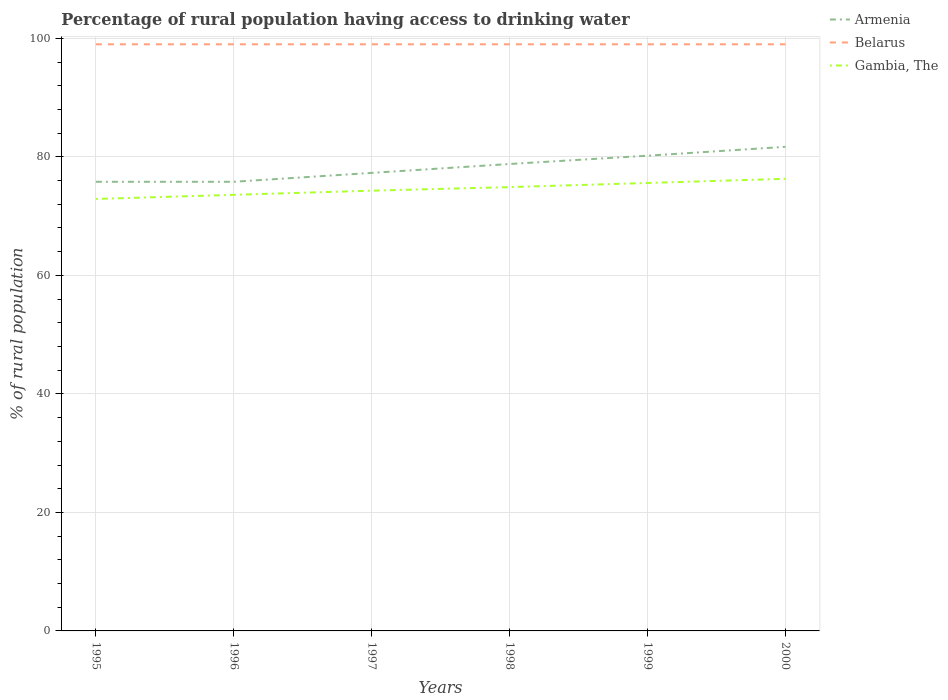Does the line corresponding to Belarus intersect with the line corresponding to Gambia, The?
Your response must be concise. No. Is the number of lines equal to the number of legend labels?
Make the answer very short. Yes. Across all years, what is the maximum percentage of rural population having access to drinking water in Armenia?
Offer a terse response. 75.8. In which year was the percentage of rural population having access to drinking water in Belarus maximum?
Offer a terse response. 1995. What is the total percentage of rural population having access to drinking water in Gambia, The in the graph?
Ensure brevity in your answer.  -0.7. What is the difference between the highest and the second highest percentage of rural population having access to drinking water in Gambia, The?
Provide a succinct answer. 3.4. Is the percentage of rural population having access to drinking water in Belarus strictly greater than the percentage of rural population having access to drinking water in Gambia, The over the years?
Your answer should be compact. No. How many lines are there?
Your response must be concise. 3. How many years are there in the graph?
Offer a terse response. 6. What is the difference between two consecutive major ticks on the Y-axis?
Ensure brevity in your answer.  20. Does the graph contain grids?
Your answer should be very brief. Yes. Where does the legend appear in the graph?
Your answer should be compact. Top right. How many legend labels are there?
Your answer should be very brief. 3. What is the title of the graph?
Give a very brief answer. Percentage of rural population having access to drinking water. What is the label or title of the X-axis?
Offer a very short reply. Years. What is the label or title of the Y-axis?
Provide a succinct answer. % of rural population. What is the % of rural population of Armenia in 1995?
Give a very brief answer. 75.8. What is the % of rural population of Belarus in 1995?
Your answer should be compact. 99. What is the % of rural population of Gambia, The in 1995?
Offer a very short reply. 72.9. What is the % of rural population in Armenia in 1996?
Your answer should be very brief. 75.8. What is the % of rural population of Belarus in 1996?
Give a very brief answer. 99. What is the % of rural population of Gambia, The in 1996?
Give a very brief answer. 73.6. What is the % of rural population of Armenia in 1997?
Provide a short and direct response. 77.3. What is the % of rural population in Gambia, The in 1997?
Ensure brevity in your answer.  74.3. What is the % of rural population in Armenia in 1998?
Offer a very short reply. 78.8. What is the % of rural population of Gambia, The in 1998?
Provide a short and direct response. 74.9. What is the % of rural population of Armenia in 1999?
Provide a succinct answer. 80.2. What is the % of rural population in Gambia, The in 1999?
Offer a terse response. 75.6. What is the % of rural population in Armenia in 2000?
Provide a succinct answer. 81.7. What is the % of rural population of Belarus in 2000?
Ensure brevity in your answer.  99. What is the % of rural population in Gambia, The in 2000?
Offer a terse response. 76.3. Across all years, what is the maximum % of rural population of Armenia?
Offer a very short reply. 81.7. Across all years, what is the maximum % of rural population in Belarus?
Offer a very short reply. 99. Across all years, what is the maximum % of rural population of Gambia, The?
Offer a terse response. 76.3. Across all years, what is the minimum % of rural population of Armenia?
Make the answer very short. 75.8. Across all years, what is the minimum % of rural population of Belarus?
Your response must be concise. 99. Across all years, what is the minimum % of rural population in Gambia, The?
Provide a short and direct response. 72.9. What is the total % of rural population of Armenia in the graph?
Make the answer very short. 469.6. What is the total % of rural population of Belarus in the graph?
Make the answer very short. 594. What is the total % of rural population of Gambia, The in the graph?
Your answer should be compact. 447.6. What is the difference between the % of rural population of Belarus in 1995 and that in 1996?
Your response must be concise. 0. What is the difference between the % of rural population of Armenia in 1995 and that in 1997?
Offer a very short reply. -1.5. What is the difference between the % of rural population of Armenia in 1995 and that in 1998?
Provide a succinct answer. -3. What is the difference between the % of rural population in Belarus in 1995 and that in 1998?
Offer a terse response. 0. What is the difference between the % of rural population in Belarus in 1995 and that in 1999?
Keep it short and to the point. 0. What is the difference between the % of rural population in Belarus in 1995 and that in 2000?
Make the answer very short. 0. What is the difference between the % of rural population of Gambia, The in 1995 and that in 2000?
Ensure brevity in your answer.  -3.4. What is the difference between the % of rural population in Armenia in 1996 and that in 1997?
Make the answer very short. -1.5. What is the difference between the % of rural population in Gambia, The in 1996 and that in 1997?
Your response must be concise. -0.7. What is the difference between the % of rural population in Armenia in 1996 and that in 1998?
Keep it short and to the point. -3. What is the difference between the % of rural population in Belarus in 1996 and that in 1998?
Your answer should be compact. 0. What is the difference between the % of rural population of Armenia in 1996 and that in 1999?
Offer a very short reply. -4.4. What is the difference between the % of rural population of Belarus in 1996 and that in 1999?
Offer a terse response. 0. What is the difference between the % of rural population of Armenia in 1996 and that in 2000?
Ensure brevity in your answer.  -5.9. What is the difference between the % of rural population of Belarus in 1996 and that in 2000?
Provide a succinct answer. 0. What is the difference between the % of rural population in Gambia, The in 1996 and that in 2000?
Provide a succinct answer. -2.7. What is the difference between the % of rural population in Belarus in 1997 and that in 1998?
Ensure brevity in your answer.  0. What is the difference between the % of rural population of Gambia, The in 1997 and that in 1998?
Make the answer very short. -0.6. What is the difference between the % of rural population of Gambia, The in 1997 and that in 1999?
Ensure brevity in your answer.  -1.3. What is the difference between the % of rural population in Belarus in 1997 and that in 2000?
Provide a short and direct response. 0. What is the difference between the % of rural population of Gambia, The in 1997 and that in 2000?
Offer a terse response. -2. What is the difference between the % of rural population in Gambia, The in 1998 and that in 1999?
Your answer should be very brief. -0.7. What is the difference between the % of rural population of Belarus in 1998 and that in 2000?
Offer a terse response. 0. What is the difference between the % of rural population in Gambia, The in 1998 and that in 2000?
Ensure brevity in your answer.  -1.4. What is the difference between the % of rural population of Armenia in 1995 and the % of rural population of Belarus in 1996?
Ensure brevity in your answer.  -23.2. What is the difference between the % of rural population of Belarus in 1995 and the % of rural population of Gambia, The in 1996?
Keep it short and to the point. 25.4. What is the difference between the % of rural population in Armenia in 1995 and the % of rural population in Belarus in 1997?
Ensure brevity in your answer.  -23.2. What is the difference between the % of rural population of Armenia in 1995 and the % of rural population of Gambia, The in 1997?
Provide a succinct answer. 1.5. What is the difference between the % of rural population in Belarus in 1995 and the % of rural population in Gambia, The in 1997?
Ensure brevity in your answer.  24.7. What is the difference between the % of rural population in Armenia in 1995 and the % of rural population in Belarus in 1998?
Give a very brief answer. -23.2. What is the difference between the % of rural population in Armenia in 1995 and the % of rural population in Gambia, The in 1998?
Your response must be concise. 0.9. What is the difference between the % of rural population of Belarus in 1995 and the % of rural population of Gambia, The in 1998?
Offer a terse response. 24.1. What is the difference between the % of rural population in Armenia in 1995 and the % of rural population in Belarus in 1999?
Make the answer very short. -23.2. What is the difference between the % of rural population in Belarus in 1995 and the % of rural population in Gambia, The in 1999?
Make the answer very short. 23.4. What is the difference between the % of rural population in Armenia in 1995 and the % of rural population in Belarus in 2000?
Offer a terse response. -23.2. What is the difference between the % of rural population in Belarus in 1995 and the % of rural population in Gambia, The in 2000?
Give a very brief answer. 22.7. What is the difference between the % of rural population in Armenia in 1996 and the % of rural population in Belarus in 1997?
Ensure brevity in your answer.  -23.2. What is the difference between the % of rural population of Armenia in 1996 and the % of rural population of Gambia, The in 1997?
Give a very brief answer. 1.5. What is the difference between the % of rural population in Belarus in 1996 and the % of rural population in Gambia, The in 1997?
Ensure brevity in your answer.  24.7. What is the difference between the % of rural population of Armenia in 1996 and the % of rural population of Belarus in 1998?
Provide a short and direct response. -23.2. What is the difference between the % of rural population in Armenia in 1996 and the % of rural population in Gambia, The in 1998?
Offer a very short reply. 0.9. What is the difference between the % of rural population in Belarus in 1996 and the % of rural population in Gambia, The in 1998?
Make the answer very short. 24.1. What is the difference between the % of rural population in Armenia in 1996 and the % of rural population in Belarus in 1999?
Make the answer very short. -23.2. What is the difference between the % of rural population of Armenia in 1996 and the % of rural population of Gambia, The in 1999?
Give a very brief answer. 0.2. What is the difference between the % of rural population in Belarus in 1996 and the % of rural population in Gambia, The in 1999?
Provide a short and direct response. 23.4. What is the difference between the % of rural population in Armenia in 1996 and the % of rural population in Belarus in 2000?
Offer a terse response. -23.2. What is the difference between the % of rural population in Armenia in 1996 and the % of rural population in Gambia, The in 2000?
Your answer should be very brief. -0.5. What is the difference between the % of rural population of Belarus in 1996 and the % of rural population of Gambia, The in 2000?
Offer a terse response. 22.7. What is the difference between the % of rural population in Armenia in 1997 and the % of rural population in Belarus in 1998?
Offer a very short reply. -21.7. What is the difference between the % of rural population in Belarus in 1997 and the % of rural population in Gambia, The in 1998?
Give a very brief answer. 24.1. What is the difference between the % of rural population in Armenia in 1997 and the % of rural population in Belarus in 1999?
Your answer should be very brief. -21.7. What is the difference between the % of rural population in Armenia in 1997 and the % of rural population in Gambia, The in 1999?
Your answer should be compact. 1.7. What is the difference between the % of rural population in Belarus in 1997 and the % of rural population in Gambia, The in 1999?
Your answer should be very brief. 23.4. What is the difference between the % of rural population in Armenia in 1997 and the % of rural population in Belarus in 2000?
Give a very brief answer. -21.7. What is the difference between the % of rural population in Armenia in 1997 and the % of rural population in Gambia, The in 2000?
Offer a terse response. 1. What is the difference between the % of rural population in Belarus in 1997 and the % of rural population in Gambia, The in 2000?
Your response must be concise. 22.7. What is the difference between the % of rural population of Armenia in 1998 and the % of rural population of Belarus in 1999?
Keep it short and to the point. -20.2. What is the difference between the % of rural population of Belarus in 1998 and the % of rural population of Gambia, The in 1999?
Your answer should be compact. 23.4. What is the difference between the % of rural population of Armenia in 1998 and the % of rural population of Belarus in 2000?
Offer a very short reply. -20.2. What is the difference between the % of rural population in Belarus in 1998 and the % of rural population in Gambia, The in 2000?
Ensure brevity in your answer.  22.7. What is the difference between the % of rural population in Armenia in 1999 and the % of rural population in Belarus in 2000?
Make the answer very short. -18.8. What is the difference between the % of rural population in Belarus in 1999 and the % of rural population in Gambia, The in 2000?
Give a very brief answer. 22.7. What is the average % of rural population of Armenia per year?
Ensure brevity in your answer.  78.27. What is the average % of rural population of Belarus per year?
Your answer should be very brief. 99. What is the average % of rural population in Gambia, The per year?
Make the answer very short. 74.6. In the year 1995, what is the difference between the % of rural population of Armenia and % of rural population of Belarus?
Your answer should be very brief. -23.2. In the year 1995, what is the difference between the % of rural population of Belarus and % of rural population of Gambia, The?
Give a very brief answer. 26.1. In the year 1996, what is the difference between the % of rural population in Armenia and % of rural population in Belarus?
Give a very brief answer. -23.2. In the year 1996, what is the difference between the % of rural population in Armenia and % of rural population in Gambia, The?
Your response must be concise. 2.2. In the year 1996, what is the difference between the % of rural population in Belarus and % of rural population in Gambia, The?
Provide a short and direct response. 25.4. In the year 1997, what is the difference between the % of rural population of Armenia and % of rural population of Belarus?
Provide a short and direct response. -21.7. In the year 1997, what is the difference between the % of rural population of Belarus and % of rural population of Gambia, The?
Your answer should be very brief. 24.7. In the year 1998, what is the difference between the % of rural population of Armenia and % of rural population of Belarus?
Your answer should be very brief. -20.2. In the year 1998, what is the difference between the % of rural population in Armenia and % of rural population in Gambia, The?
Your answer should be compact. 3.9. In the year 1998, what is the difference between the % of rural population in Belarus and % of rural population in Gambia, The?
Ensure brevity in your answer.  24.1. In the year 1999, what is the difference between the % of rural population of Armenia and % of rural population of Belarus?
Provide a succinct answer. -18.8. In the year 1999, what is the difference between the % of rural population of Belarus and % of rural population of Gambia, The?
Provide a short and direct response. 23.4. In the year 2000, what is the difference between the % of rural population of Armenia and % of rural population of Belarus?
Your answer should be very brief. -17.3. In the year 2000, what is the difference between the % of rural population of Belarus and % of rural population of Gambia, The?
Ensure brevity in your answer.  22.7. What is the ratio of the % of rural population in Armenia in 1995 to that in 1996?
Offer a very short reply. 1. What is the ratio of the % of rural population of Belarus in 1995 to that in 1996?
Keep it short and to the point. 1. What is the ratio of the % of rural population in Gambia, The in 1995 to that in 1996?
Your answer should be compact. 0.99. What is the ratio of the % of rural population in Armenia in 1995 to that in 1997?
Your response must be concise. 0.98. What is the ratio of the % of rural population of Belarus in 1995 to that in 1997?
Provide a succinct answer. 1. What is the ratio of the % of rural population in Gambia, The in 1995 to that in 1997?
Provide a succinct answer. 0.98. What is the ratio of the % of rural population in Armenia in 1995 to that in 1998?
Your answer should be very brief. 0.96. What is the ratio of the % of rural population in Gambia, The in 1995 to that in 1998?
Your response must be concise. 0.97. What is the ratio of the % of rural population of Armenia in 1995 to that in 1999?
Your response must be concise. 0.95. What is the ratio of the % of rural population of Belarus in 1995 to that in 1999?
Your answer should be compact. 1. What is the ratio of the % of rural population of Armenia in 1995 to that in 2000?
Provide a succinct answer. 0.93. What is the ratio of the % of rural population of Gambia, The in 1995 to that in 2000?
Offer a terse response. 0.96. What is the ratio of the % of rural population in Armenia in 1996 to that in 1997?
Your answer should be very brief. 0.98. What is the ratio of the % of rural population of Belarus in 1996 to that in 1997?
Provide a short and direct response. 1. What is the ratio of the % of rural population in Gambia, The in 1996 to that in 1997?
Your response must be concise. 0.99. What is the ratio of the % of rural population of Armenia in 1996 to that in 1998?
Your response must be concise. 0.96. What is the ratio of the % of rural population in Belarus in 1996 to that in 1998?
Your answer should be compact. 1. What is the ratio of the % of rural population in Gambia, The in 1996 to that in 1998?
Make the answer very short. 0.98. What is the ratio of the % of rural population of Armenia in 1996 to that in 1999?
Offer a very short reply. 0.95. What is the ratio of the % of rural population in Gambia, The in 1996 to that in 1999?
Your answer should be compact. 0.97. What is the ratio of the % of rural population in Armenia in 1996 to that in 2000?
Make the answer very short. 0.93. What is the ratio of the % of rural population in Belarus in 1996 to that in 2000?
Make the answer very short. 1. What is the ratio of the % of rural population of Gambia, The in 1996 to that in 2000?
Make the answer very short. 0.96. What is the ratio of the % of rural population of Armenia in 1997 to that in 1998?
Ensure brevity in your answer.  0.98. What is the ratio of the % of rural population of Belarus in 1997 to that in 1998?
Your answer should be very brief. 1. What is the ratio of the % of rural population of Gambia, The in 1997 to that in 1998?
Provide a succinct answer. 0.99. What is the ratio of the % of rural population of Armenia in 1997 to that in 1999?
Provide a short and direct response. 0.96. What is the ratio of the % of rural population in Belarus in 1997 to that in 1999?
Your answer should be very brief. 1. What is the ratio of the % of rural population of Gambia, The in 1997 to that in 1999?
Give a very brief answer. 0.98. What is the ratio of the % of rural population of Armenia in 1997 to that in 2000?
Give a very brief answer. 0.95. What is the ratio of the % of rural population of Gambia, The in 1997 to that in 2000?
Offer a terse response. 0.97. What is the ratio of the % of rural population in Armenia in 1998 to that in 1999?
Your answer should be compact. 0.98. What is the ratio of the % of rural population in Armenia in 1998 to that in 2000?
Give a very brief answer. 0.96. What is the ratio of the % of rural population of Belarus in 1998 to that in 2000?
Your answer should be compact. 1. What is the ratio of the % of rural population in Gambia, The in 1998 to that in 2000?
Provide a succinct answer. 0.98. What is the ratio of the % of rural population in Armenia in 1999 to that in 2000?
Give a very brief answer. 0.98. What is the ratio of the % of rural population of Gambia, The in 1999 to that in 2000?
Your response must be concise. 0.99. What is the difference between the highest and the second highest % of rural population of Armenia?
Ensure brevity in your answer.  1.5. What is the difference between the highest and the lowest % of rural population of Armenia?
Your answer should be very brief. 5.9. 